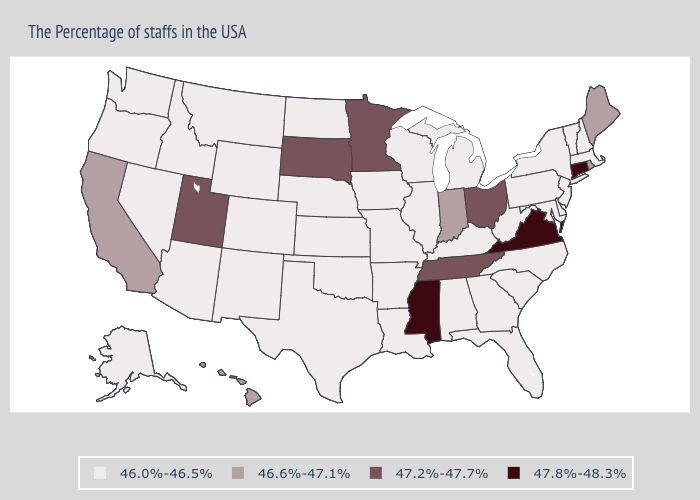Which states have the lowest value in the West?
Answer briefly. Wyoming, Colorado, New Mexico, Montana, Arizona, Idaho, Nevada, Washington, Oregon, Alaska. What is the lowest value in the MidWest?
Quick response, please. 46.0%-46.5%. Name the states that have a value in the range 46.0%-46.5%?
Quick response, please. Massachusetts, New Hampshire, Vermont, New York, New Jersey, Delaware, Maryland, Pennsylvania, North Carolina, South Carolina, West Virginia, Florida, Georgia, Michigan, Kentucky, Alabama, Wisconsin, Illinois, Louisiana, Missouri, Arkansas, Iowa, Kansas, Nebraska, Oklahoma, Texas, North Dakota, Wyoming, Colorado, New Mexico, Montana, Arizona, Idaho, Nevada, Washington, Oregon, Alaska. Which states hav the highest value in the MidWest?
Short answer required. Ohio, Minnesota, South Dakota. What is the value of North Dakota?
Keep it brief. 46.0%-46.5%. Does the first symbol in the legend represent the smallest category?
Give a very brief answer. Yes. What is the value of New York?
Keep it brief. 46.0%-46.5%. Which states have the lowest value in the USA?
Be succinct. Massachusetts, New Hampshire, Vermont, New York, New Jersey, Delaware, Maryland, Pennsylvania, North Carolina, South Carolina, West Virginia, Florida, Georgia, Michigan, Kentucky, Alabama, Wisconsin, Illinois, Louisiana, Missouri, Arkansas, Iowa, Kansas, Nebraska, Oklahoma, Texas, North Dakota, Wyoming, Colorado, New Mexico, Montana, Arizona, Idaho, Nevada, Washington, Oregon, Alaska. Which states have the lowest value in the USA?
Keep it brief. Massachusetts, New Hampshire, Vermont, New York, New Jersey, Delaware, Maryland, Pennsylvania, North Carolina, South Carolina, West Virginia, Florida, Georgia, Michigan, Kentucky, Alabama, Wisconsin, Illinois, Louisiana, Missouri, Arkansas, Iowa, Kansas, Nebraska, Oklahoma, Texas, North Dakota, Wyoming, Colorado, New Mexico, Montana, Arizona, Idaho, Nevada, Washington, Oregon, Alaska. Among the states that border Alabama , which have the highest value?
Keep it brief. Mississippi. Which states hav the highest value in the West?
Give a very brief answer. Utah. Which states have the lowest value in the USA?
Write a very short answer. Massachusetts, New Hampshire, Vermont, New York, New Jersey, Delaware, Maryland, Pennsylvania, North Carolina, South Carolina, West Virginia, Florida, Georgia, Michigan, Kentucky, Alabama, Wisconsin, Illinois, Louisiana, Missouri, Arkansas, Iowa, Kansas, Nebraska, Oklahoma, Texas, North Dakota, Wyoming, Colorado, New Mexico, Montana, Arizona, Idaho, Nevada, Washington, Oregon, Alaska. Which states hav the highest value in the South?
Write a very short answer. Virginia, Mississippi. What is the value of Washington?
Answer briefly. 46.0%-46.5%. What is the value of North Dakota?
Keep it brief. 46.0%-46.5%. 